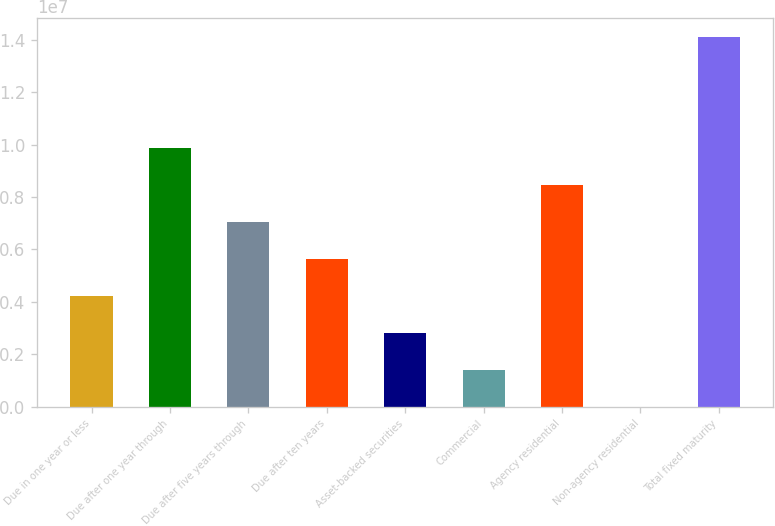<chart> <loc_0><loc_0><loc_500><loc_500><bar_chart><fcel>Due in one year or less<fcel>Due after one year through<fcel>Due after five years through<fcel>Due after ten years<fcel>Asset-backed securities<fcel>Commercial<fcel>Agency residential<fcel>Non-agency residential<fcel>Total fixed maturity<nl><fcel>4.23267e+06<fcel>9.87538e+06<fcel>7.05402e+06<fcel>5.64335e+06<fcel>2.82199e+06<fcel>1.41132e+06<fcel>8.4647e+06<fcel>641<fcel>1.41074e+07<nl></chart> 